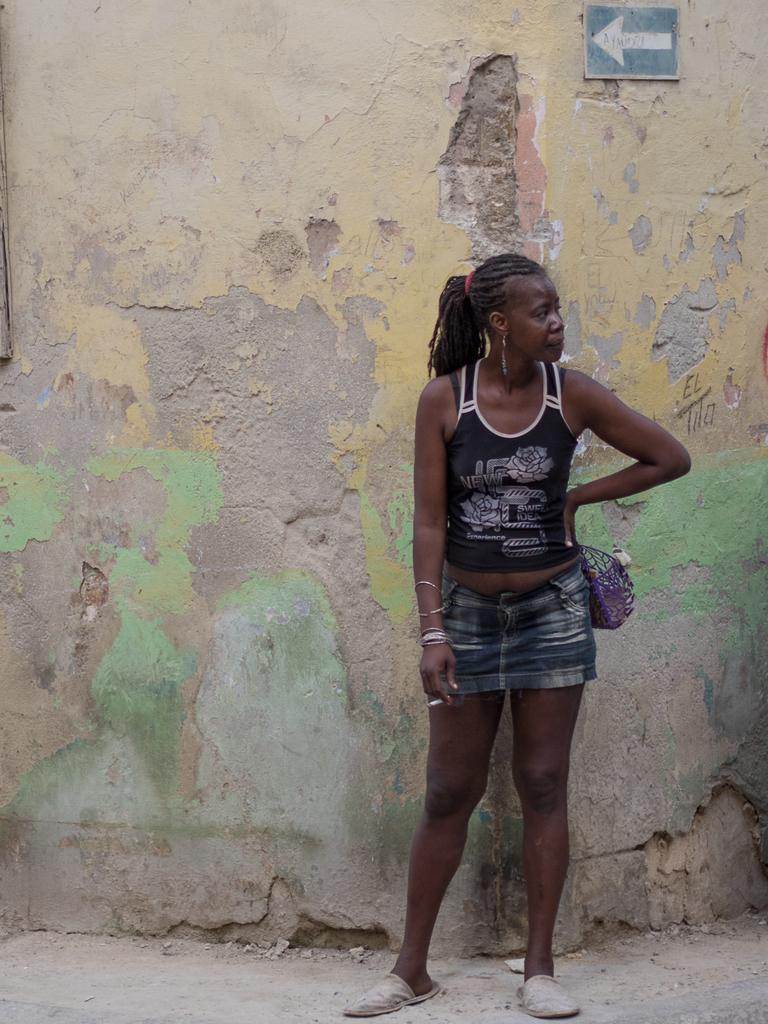What is the woman in the image doing? The woman is standing on a path in the image. What can be seen beside the woman? There is a purple object beside the woman. What is the condition of the wall in the image? There are cracks visible on a wall in the image. What is attached to the wall in the image? There is a tent on the wall in the image. How many boys are playing in the shade in the image? There are no boys or shaded areas present in the image. 